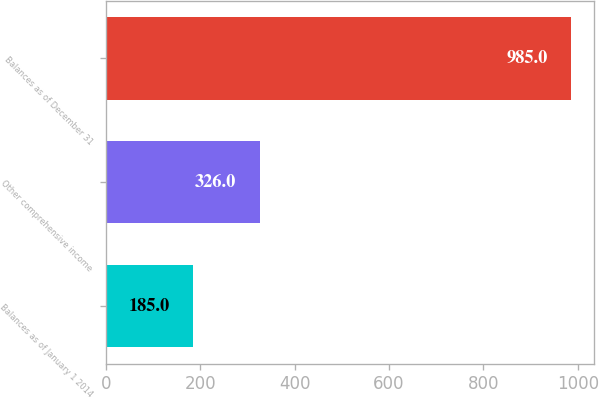<chart> <loc_0><loc_0><loc_500><loc_500><bar_chart><fcel>Balances as of January 1 2014<fcel>Other comprehensive income<fcel>Balances as of December 31<nl><fcel>185<fcel>326<fcel>985<nl></chart> 